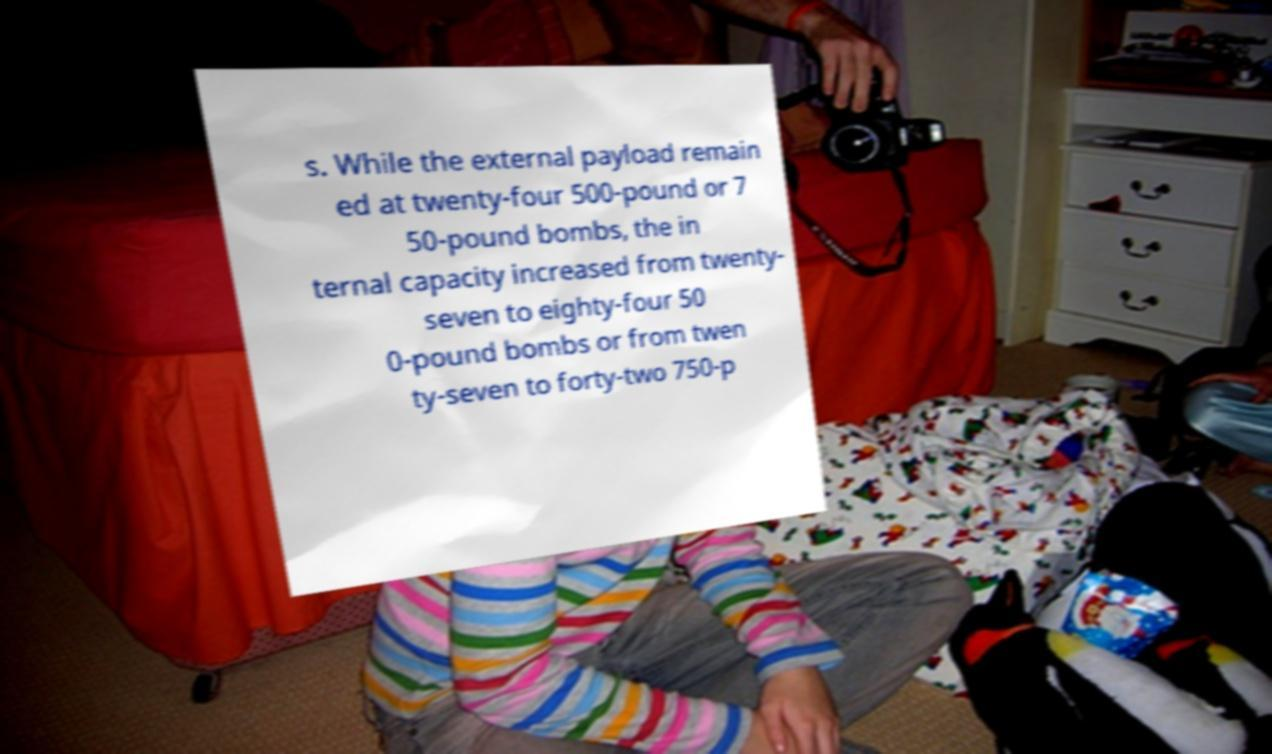Can you accurately transcribe the text from the provided image for me? s. While the external payload remain ed at twenty-four 500-pound or 7 50-pound bombs, the in ternal capacity increased from twenty- seven to eighty-four 50 0-pound bombs or from twen ty-seven to forty-two 750-p 